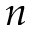<formula> <loc_0><loc_0><loc_500><loc_500>n</formula> 